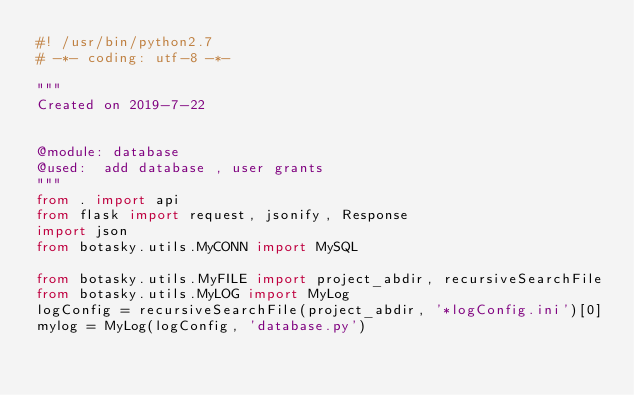<code> <loc_0><loc_0><loc_500><loc_500><_Python_>#! /usr/bin/python2.7
# -*- coding: utf-8 -*-

"""
Created on 2019-7-22


@module: database
@used:  add database , user grants
"""
from . import api
from flask import request, jsonify, Response
import json
from botasky.utils.MyCONN import MySQL

from botasky.utils.MyFILE import project_abdir, recursiveSearchFile
from botasky.utils.MyLOG import MyLog
logConfig = recursiveSearchFile(project_abdir, '*logConfig.ini')[0]
mylog = MyLog(logConfig, 'database.py')</code> 